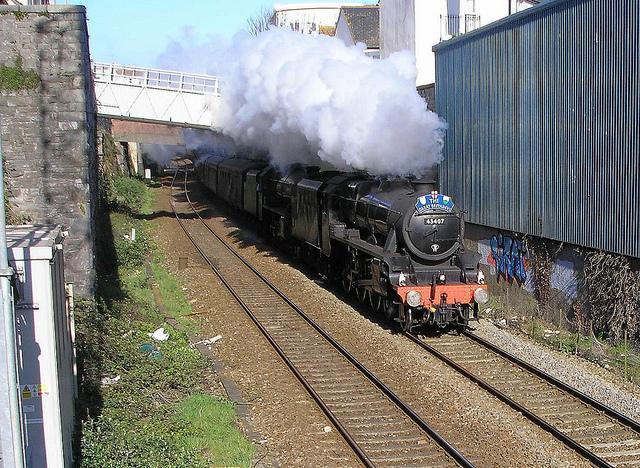How many train tracks are in this picture?
Give a very brief answer. 2. 